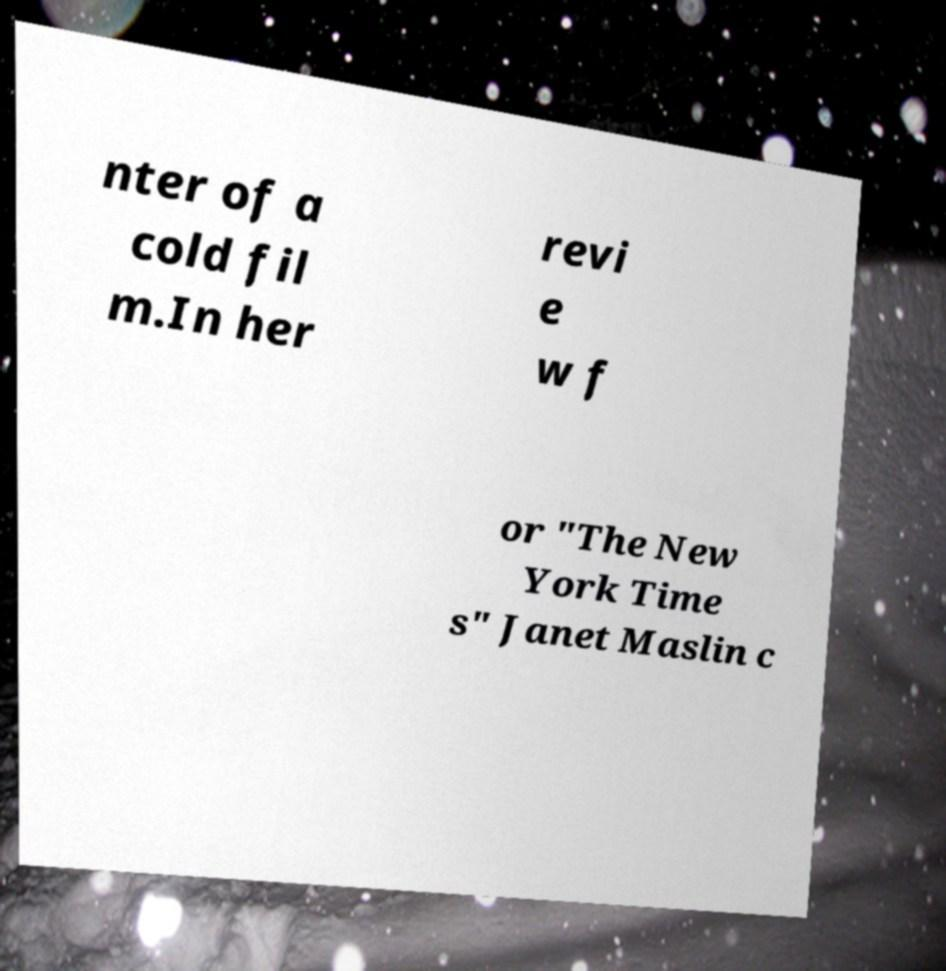What messages or text are displayed in this image? I need them in a readable, typed format. nter of a cold fil m.In her revi e w f or "The New York Time s" Janet Maslin c 